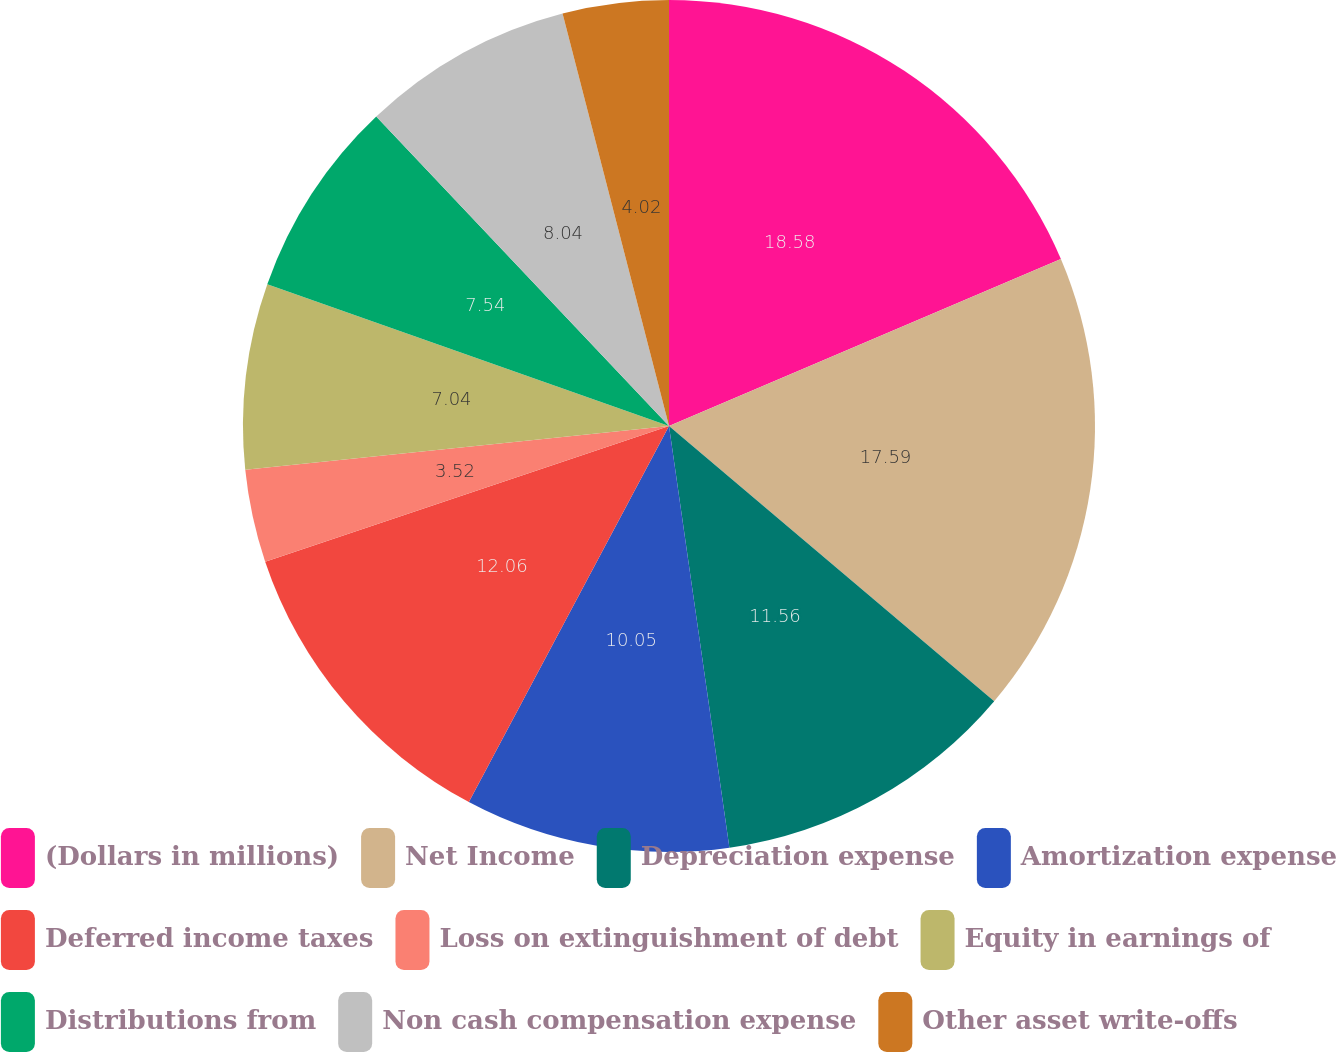Convert chart to OTSL. <chart><loc_0><loc_0><loc_500><loc_500><pie_chart><fcel>(Dollars in millions)<fcel>Net Income<fcel>Depreciation expense<fcel>Amortization expense<fcel>Deferred income taxes<fcel>Loss on extinguishment of debt<fcel>Equity in earnings of<fcel>Distributions from<fcel>Non cash compensation expense<fcel>Other asset write-offs<nl><fcel>18.59%<fcel>17.59%<fcel>11.56%<fcel>10.05%<fcel>12.06%<fcel>3.52%<fcel>7.04%<fcel>7.54%<fcel>8.04%<fcel>4.02%<nl></chart> 